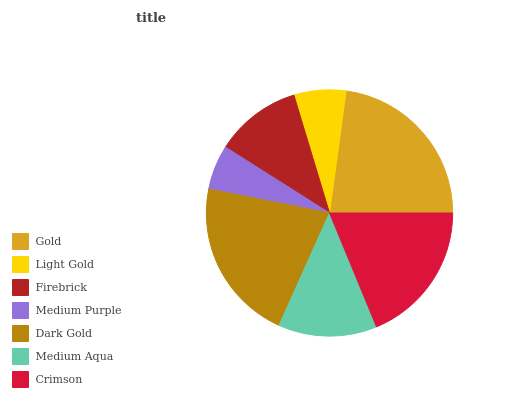Is Medium Purple the minimum?
Answer yes or no. Yes. Is Gold the maximum?
Answer yes or no. Yes. Is Light Gold the minimum?
Answer yes or no. No. Is Light Gold the maximum?
Answer yes or no. No. Is Gold greater than Light Gold?
Answer yes or no. Yes. Is Light Gold less than Gold?
Answer yes or no. Yes. Is Light Gold greater than Gold?
Answer yes or no. No. Is Gold less than Light Gold?
Answer yes or no. No. Is Medium Aqua the high median?
Answer yes or no. Yes. Is Medium Aqua the low median?
Answer yes or no. Yes. Is Dark Gold the high median?
Answer yes or no. No. Is Medium Purple the low median?
Answer yes or no. No. 